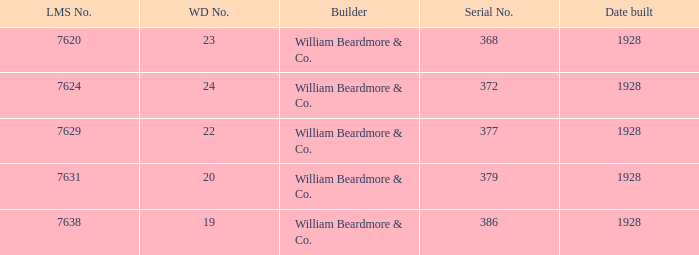Who is the maker for serial number having 377? William Beardmore & Co. 